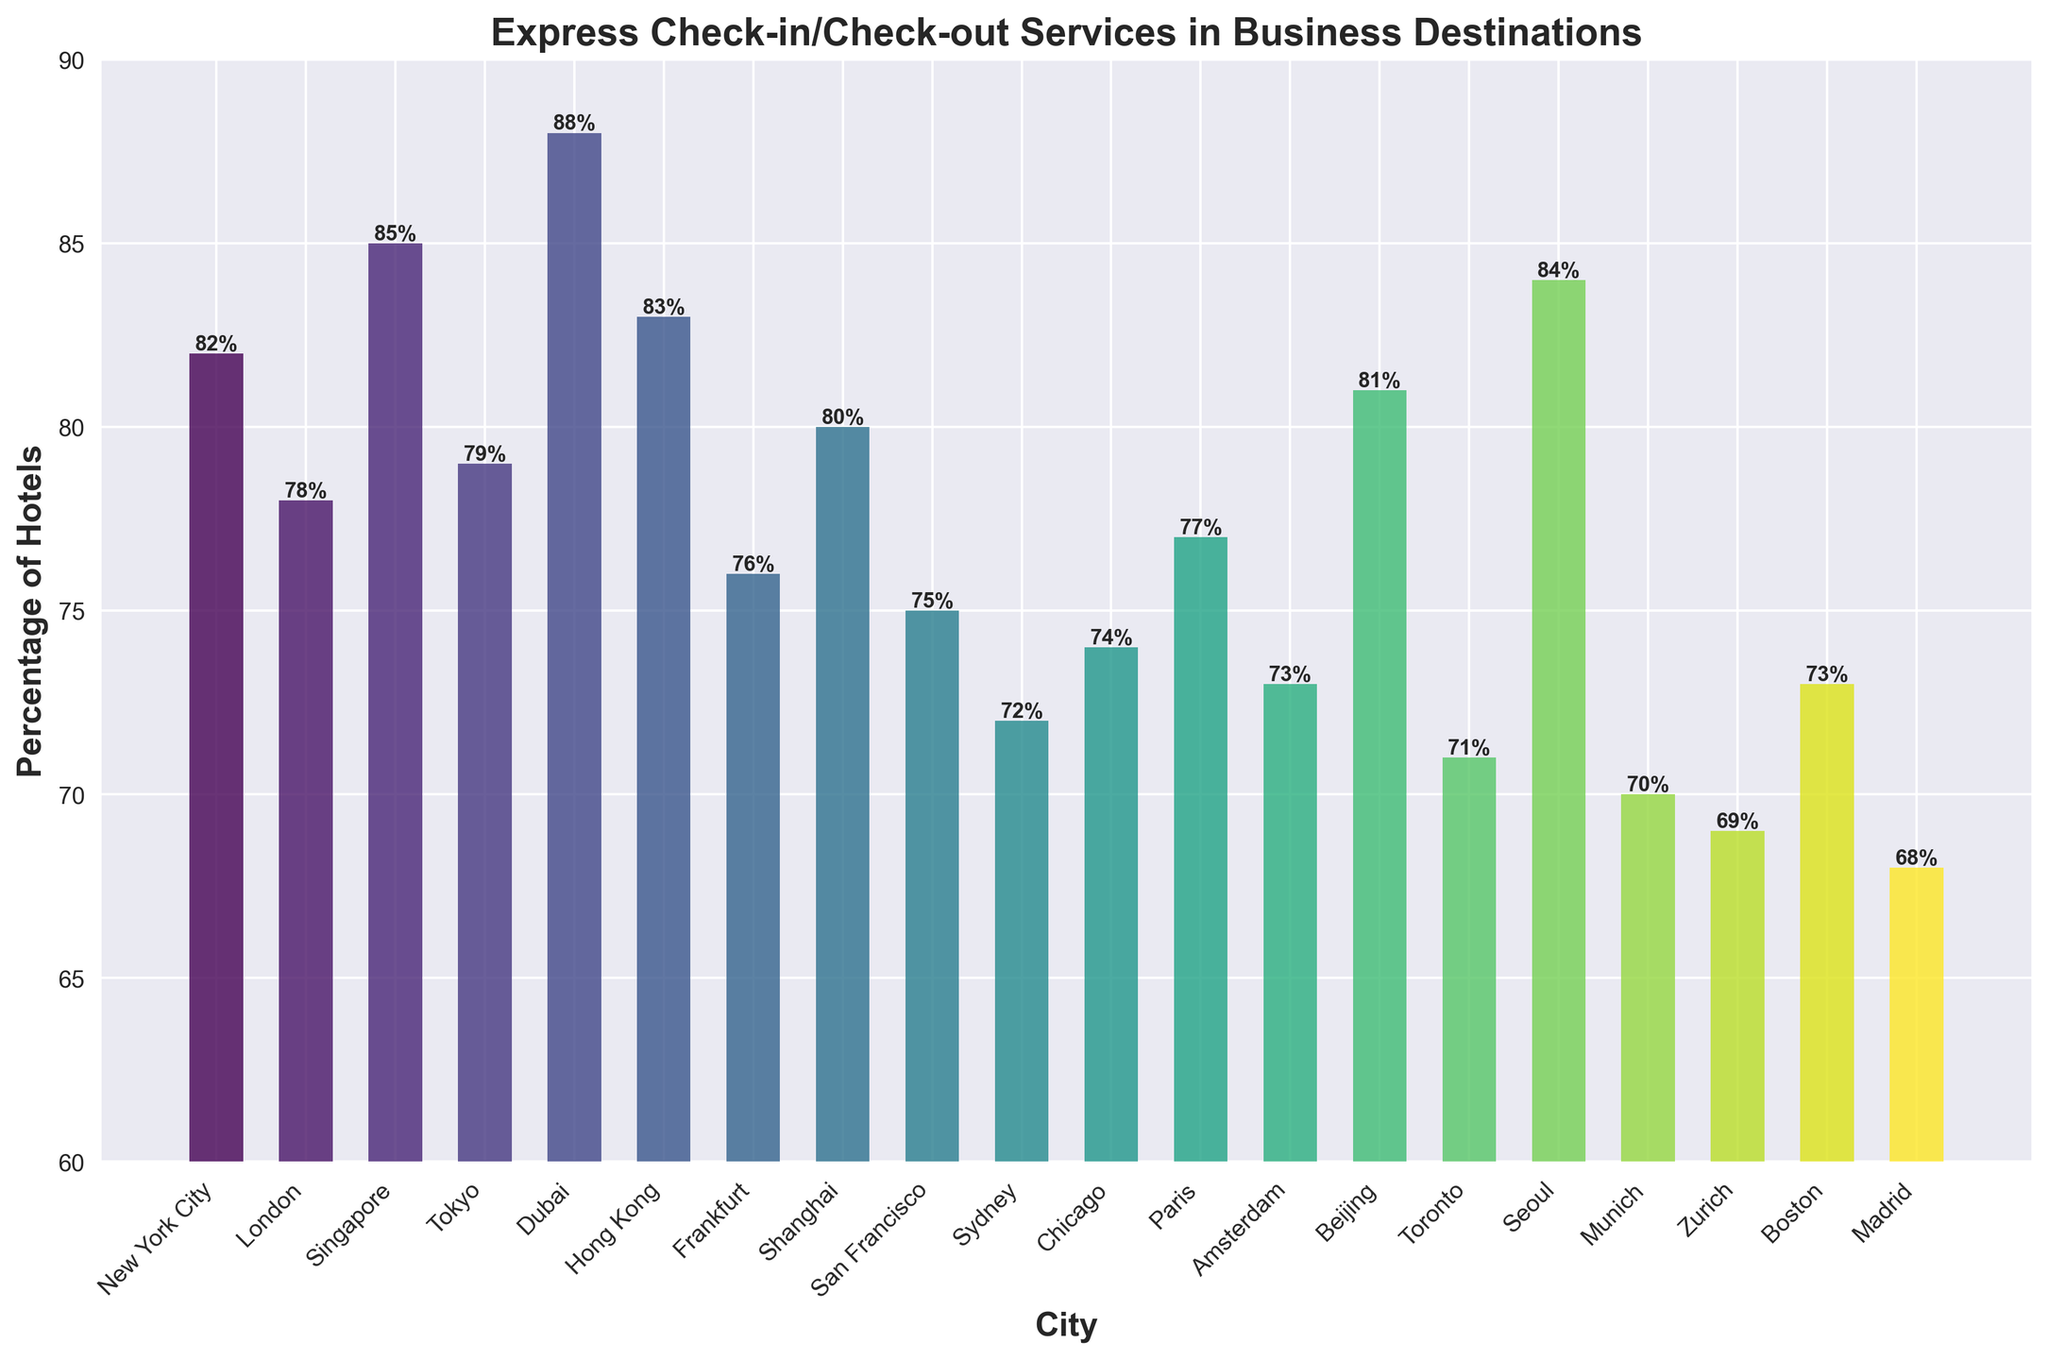What percentage of hotels in Dubai offer express check-in/check-out services? We simply read the bar corresponding to Dubai in the chart to find the percentage value.
Answer: 88% Which city has the lowest percentage of hotels offering express check-in/check-out services? By comparing the heights of all the bars, we see that the bar corresponding to Madrid is the shortest.
Answer: Madrid Between New York City and San Francisco, which city offers a higher percentage of hotels with express check-in/check-out services? Compare the heights of the bars for New York City and San Francisco. The bar for New York City is higher.
Answer: New York City What is the average percentage of hotels offering express check-in/check-out services in New York City, London, and Tokyo? Add the percentages for New York City (82%), London (78%), and Tokyo (79%) and then divide by 3. Calculation: (82 + 78 + 79) / 3 = 79.67%
Answer: 79.67% How much higher is the percentage of hotels with express check-in/check-out services in Singapore compared to Paris? Subtract the percentage for Paris (77%) from the percentage for Singapore (85%). Calculation: 85 - 77 = 8%
Answer: 8% Which cities have a percentage of hotels with express check-in/check-out services greater than 80%? Identify the bars that are above the 80% mark. These cities are: New York City, Singapore, Dubai, Hong Kong, Beijing, and Seoul.
Answer: New York City, Singapore, Dubai, Hong Kong, Beijing, Seoul Is the percentage of hotels with express check-in/check-out services higher in Zurich or in Munich? Compare the heights of the bars for Zurich and Munich. The bar for Munich is slightly higher.
Answer: Munich What is the range of percentages of hotels offering express check-in/check-out services among the listed cities? Subtract the lowest percentage (Madrid, 68%) from the highest percentage (Dubai, 88%). Calculation: 88 - 68 = 20%.
Answer: 20% How does the percentage of hotels with express check-in/check-out services in Chicago compare to that in Amsterdam? Compare the heights of the bars for Chicago (74%) and Amsterdam (73%). Chicago’s bar is slightly higher.
Answer: Chicago by 1% Which city offers just above three-fourths (75%) level of hotels providing express check-in/check-out services? Look for the bar slightly above the 75% mark. The relevant city is Shanghai with 80%.
Answer: Shanghai 